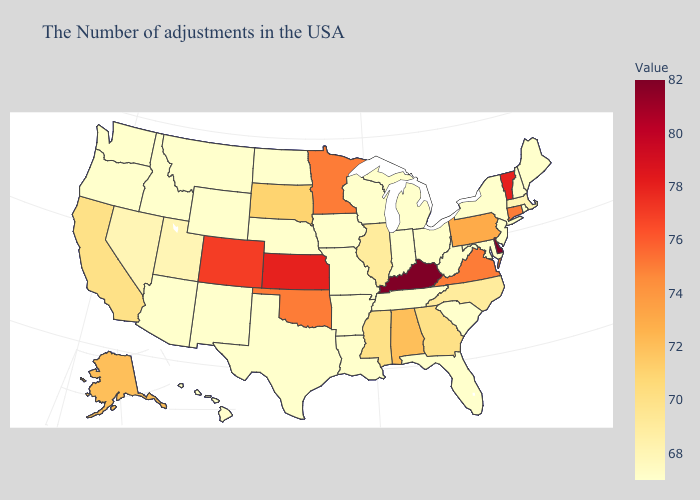Which states have the highest value in the USA?
Answer briefly. Delaware, Kentucky. Which states have the lowest value in the MidWest?
Write a very short answer. Ohio, Michigan, Indiana, Wisconsin, Missouri, Iowa, Nebraska, North Dakota. Which states have the lowest value in the USA?
Answer briefly. Maine, Rhode Island, New Hampshire, New York, New Jersey, Maryland, South Carolina, West Virginia, Ohio, Florida, Michigan, Indiana, Tennessee, Wisconsin, Louisiana, Missouri, Arkansas, Iowa, Nebraska, Texas, North Dakota, Wyoming, New Mexico, Montana, Arizona, Idaho, Washington, Oregon, Hawaii. 